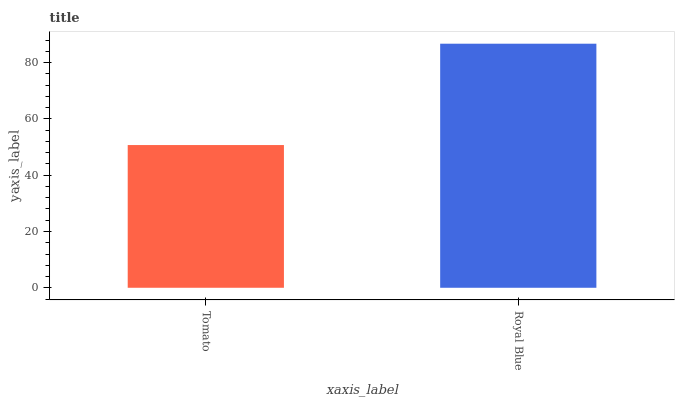Is Tomato the minimum?
Answer yes or no. Yes. Is Royal Blue the maximum?
Answer yes or no. Yes. Is Royal Blue the minimum?
Answer yes or no. No. Is Royal Blue greater than Tomato?
Answer yes or no. Yes. Is Tomato less than Royal Blue?
Answer yes or no. Yes. Is Tomato greater than Royal Blue?
Answer yes or no. No. Is Royal Blue less than Tomato?
Answer yes or no. No. Is Royal Blue the high median?
Answer yes or no. Yes. Is Tomato the low median?
Answer yes or no. Yes. Is Tomato the high median?
Answer yes or no. No. Is Royal Blue the low median?
Answer yes or no. No. 